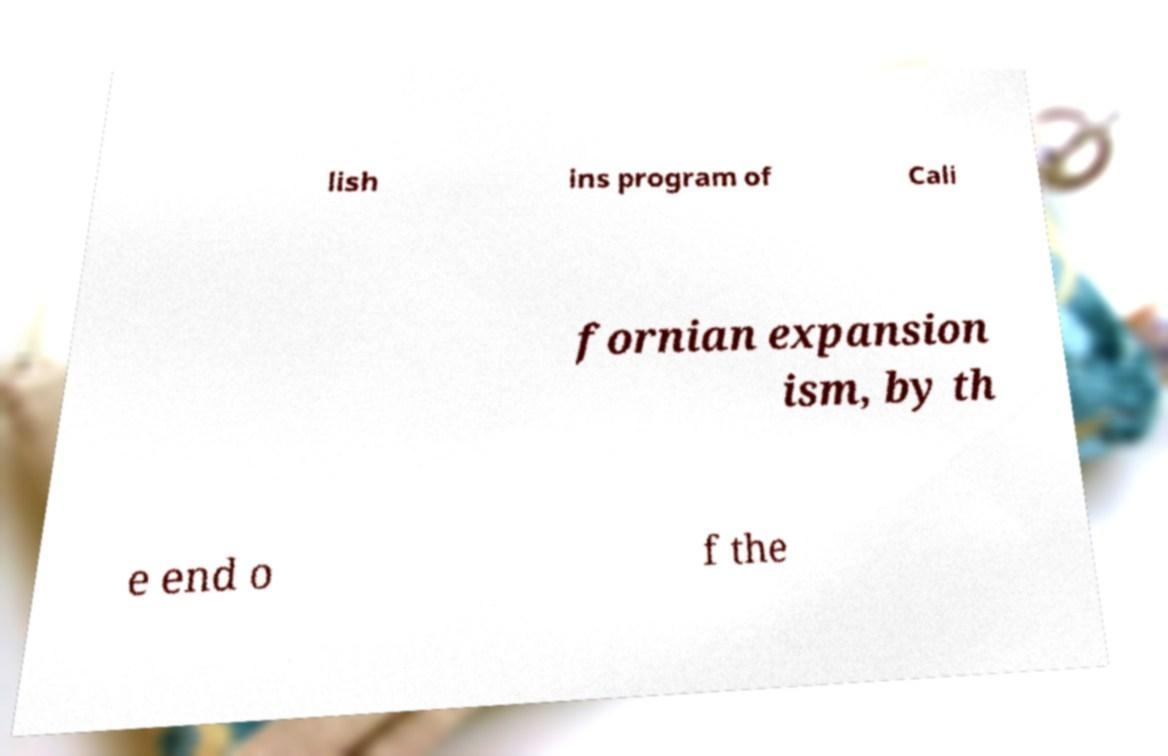Please identify and transcribe the text found in this image. lish ins program of Cali fornian expansion ism, by th e end o f the 